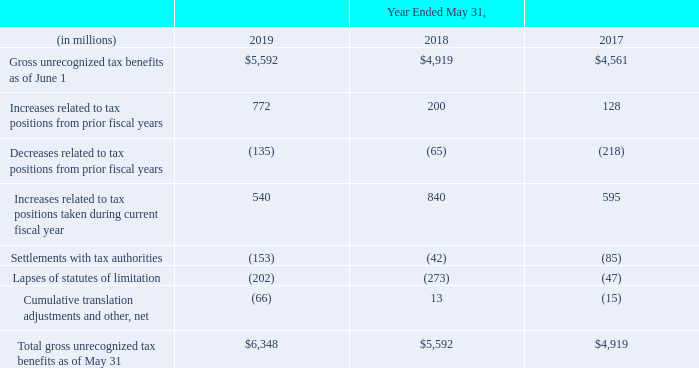At May 31, 201 9 , we had federal net operating loss carryforwards of approximately $ 732 million, which are subject to limitation on their utilization. Approximately $ 690 million of these federal net operating losses expire in various years between fiscal 2020 and fiscal 2018 . Approximately $42 million of these federal net operating losses are not currently subject to expiration dates. We had state net operating loss carryforwards of approximately $ 2.2 billion at May 31, 2019 , which expire between fiscal 2020 and fiscal 2018 and are subject to limitations on their utilization. We had total foreign net operating loss carryforwards of approximately $ 2.0 billion at May 31, 2019 , which are subject to limitations on their utilization. Approximately $ 1.9 billion of these foreign net operating losses are not currently subject to expiration dates. The remainder of the foreign net operating losses, approximately $ 100 million, expire between fiscal 2020 and fiscal 2019. We had tax credit carryforwards of approximately $ 1.1 billion at May 31, 2019 , which are subject to limitations on their utilization. Approximately $ 734 million of these tax credit carryforwards are not current ly subject to expiration dates. The remainder of the tax credit carryforwards, approximately $ 387 million, expire in various years between fiscal 2020 and fiscal 2019
We classify our unrecognized tax benefits as either current or non-current income taxes payable in the accompanying consolidated balance sheets. The aggregate changes in the balance of our gross unrecognized tax benefits, including acquisitions, were as follows:
As of May 31, 2019, 2018 and 2017, $4.2 billion, $4.2 billion and $3.4 billion, respectively, of unrecognized tax benefits would affect our effective tax rate if recognized. We recognized interest and penalties related to uncertain tax positions in our provision for income taxes line of our consolidated statements of operations of $312 million, $127 million and $125 million during fiscal 2019, 2018 and 2017, respectively. Interest and penalties accrued as of May 31, 2019 and 2018 were $1.3 billion and $992 million, respectively.
Domestically, U.S. federal and state taxing authorities are currently examining income tax returns of Oracle and various acquired entities for years through fiscal 2017. Many issues are at an advanced stage in the examination process, the most significant of which include the deductibility of certain royalty payments, transfer pricing, extraterritorial income exemptions, domestic production activity, foreign tax credits, and research and development credits taken. With all of these domestic audit issues considered in the aggregate, we believe that it was reasonably possible that, as of May 31, 2019, the gross unrecognized tax benefits related to these audits could decrease (whether by payment, release, or a combination of both) in the next 12 months by as much as $516 million ($357 million net of offsetting tax benefits). Our U.S. federal income tax returns have been examined for all years prior to fiscal 2010 and we are no longer subject to audit for those periods. Our U.S. state income tax returns, with some exceptions, have been examined for all years prior to fiscal 2007 and we are no longer subject to audit for those periods.
Internationally, tax authorities for numerous non-U.S. jurisdictions are also examining returns affecting our unrecognized tax benefits. We believe that it was reasonably possible that, as of May 31, 2019, the gross unrecognized tax benefits could decrease (whether by payment, release, or a combination of both) by as much as $186 million ($87 million net of offsetting tax benefits) in the next 12 months related primarily to transfer pricing.
What was the percentage change in "increases related to tax positions taken during current fiscal year" from 2017 to 2018?
Answer scale should be: percent. (840-595)/595 
Answer: 41.18. What percentage of the gross unrecognized tax benefits as of June 1 in 2019 would affect the company's effective tax rate if recognised?
Answer scale should be: percent. 4.2 billion / 5,592 million 
Answer: 75.11. What was the total interest and penalties accrued as of May 31, 2019 and 2018 in millions?
Answer scale should be: million. 1.3 billion + 992 million 
Answer: 2292. Does oracle believe that the gross unrecognized tax benefits could decrease? We believe that it was reasonably possible that, as of may 31, 2019, the gross unrecognized tax benefits could decrease (whether by payment, release, or a combination of both) by as much as $186 million ($87 million net of offsetting tax benefits) in the next 12 months related primarily to transfer pricing. What areas are being examined by the US federal and state taxing authorities, internationally and domestically? Domestically, u.s. federal and state taxing authorities are currently examining income tax returns of oracle and various acquired entities for years through fiscal 2017, internationally, tax authorities for numerous non-u.s. jurisdictions are also examining returns affecting our unrecognized tax benefits. How does oracle classify its unrecognized tax benefits? We classify our unrecognized tax benefits as either current or non-current income taxes payable in the accompanying consolidated balance sheets. 